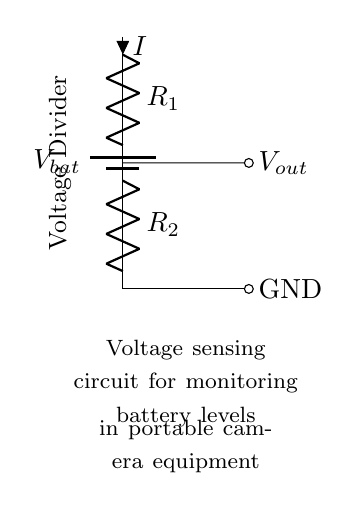What is the total voltage in this circuit? The total voltage is equal to the voltage of the battery, indicated as V_bat in the circuit.
Answer: V_bat What are the resistances in this voltage divider? The resistances in the voltage divider are R_1 and R_2. They are labeled clearly in the circuit diagram.
Answer: R_1, R_2 What is the output voltage taken from the circuit? The output voltage can be determined by observing where V_out is connected, which is at the junction between R_1 and R_2 in the circuit.
Answer: V_out Which component directly monitors the battery levels? The battery component labeled as V_bat directly represents the source for monitoring battery levels in the circuit.
Answer: V_bat How does the current flow in this circuit? The current flows from the battery V_bat through R_1 and then through R_2 to ground, indicating a loop throughout the components.
Answer: From V_bat to ground What role does the resistor R_1 play in this voltage divider? Resistor R_1 contributes to the division of voltage between itself and R_2, affecting the output voltage available at V_out.
Answer: Divides voltage What happens to the output voltage if R_2 is increased? If R_2 is increased while R_1 remains constant, the output voltage V_out will increase according to the voltage divider formula, which depends on the ratio of the two resistances.
Answer: V_out increases 